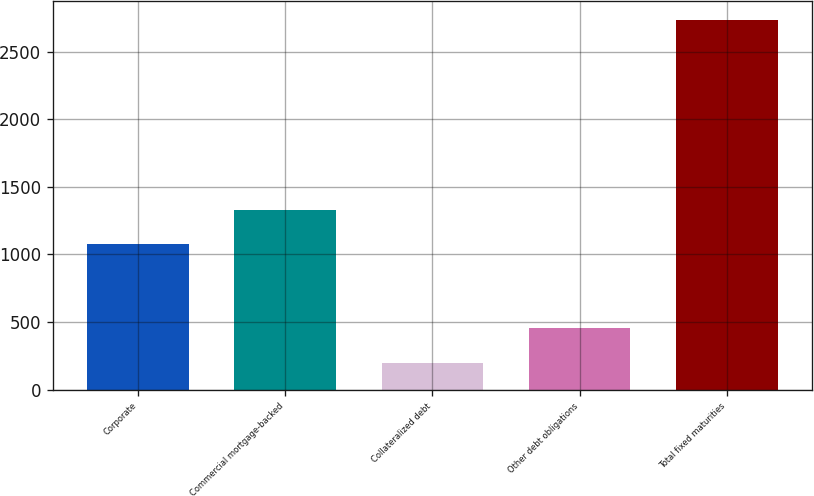Convert chart to OTSL. <chart><loc_0><loc_0><loc_500><loc_500><bar_chart><fcel>Corporate<fcel>Commercial mortgage-backed<fcel>Collateralized debt<fcel>Other debt obligations<fcel>Total fixed maturities<nl><fcel>1075<fcel>1328.55<fcel>200.7<fcel>454.25<fcel>2736.2<nl></chart> 